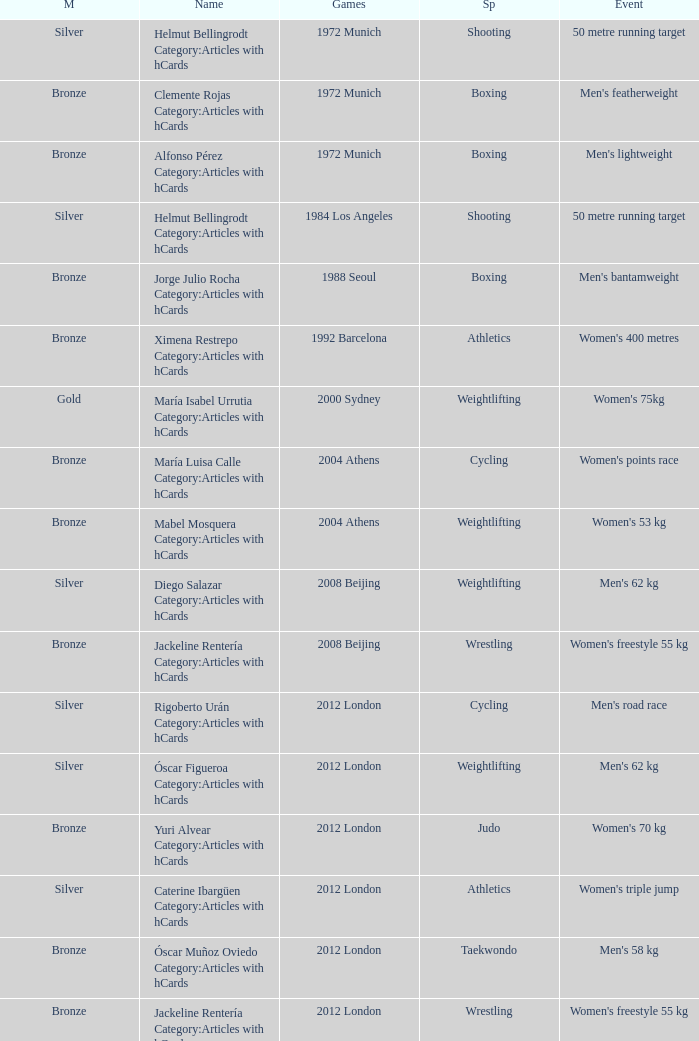What wrestling event was participated in during the 2008 Beijing games? Women's freestyle 55 kg. 